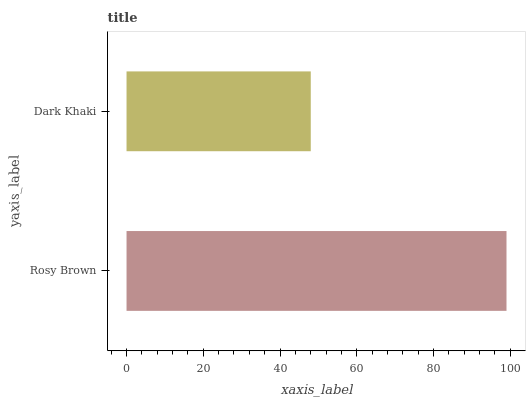Is Dark Khaki the minimum?
Answer yes or no. Yes. Is Rosy Brown the maximum?
Answer yes or no. Yes. Is Dark Khaki the maximum?
Answer yes or no. No. Is Rosy Brown greater than Dark Khaki?
Answer yes or no. Yes. Is Dark Khaki less than Rosy Brown?
Answer yes or no. Yes. Is Dark Khaki greater than Rosy Brown?
Answer yes or no. No. Is Rosy Brown less than Dark Khaki?
Answer yes or no. No. Is Rosy Brown the high median?
Answer yes or no. Yes. Is Dark Khaki the low median?
Answer yes or no. Yes. Is Dark Khaki the high median?
Answer yes or no. No. Is Rosy Brown the low median?
Answer yes or no. No. 